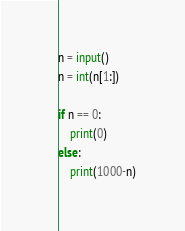Convert code to text. <code><loc_0><loc_0><loc_500><loc_500><_Python_>n = input()
n = int(n[1:])

if n == 0:
    print(0)
else:
    print(1000-n)</code> 